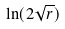Convert formula to latex. <formula><loc_0><loc_0><loc_500><loc_500>\ln ( 2 \sqrt { r } )</formula> 